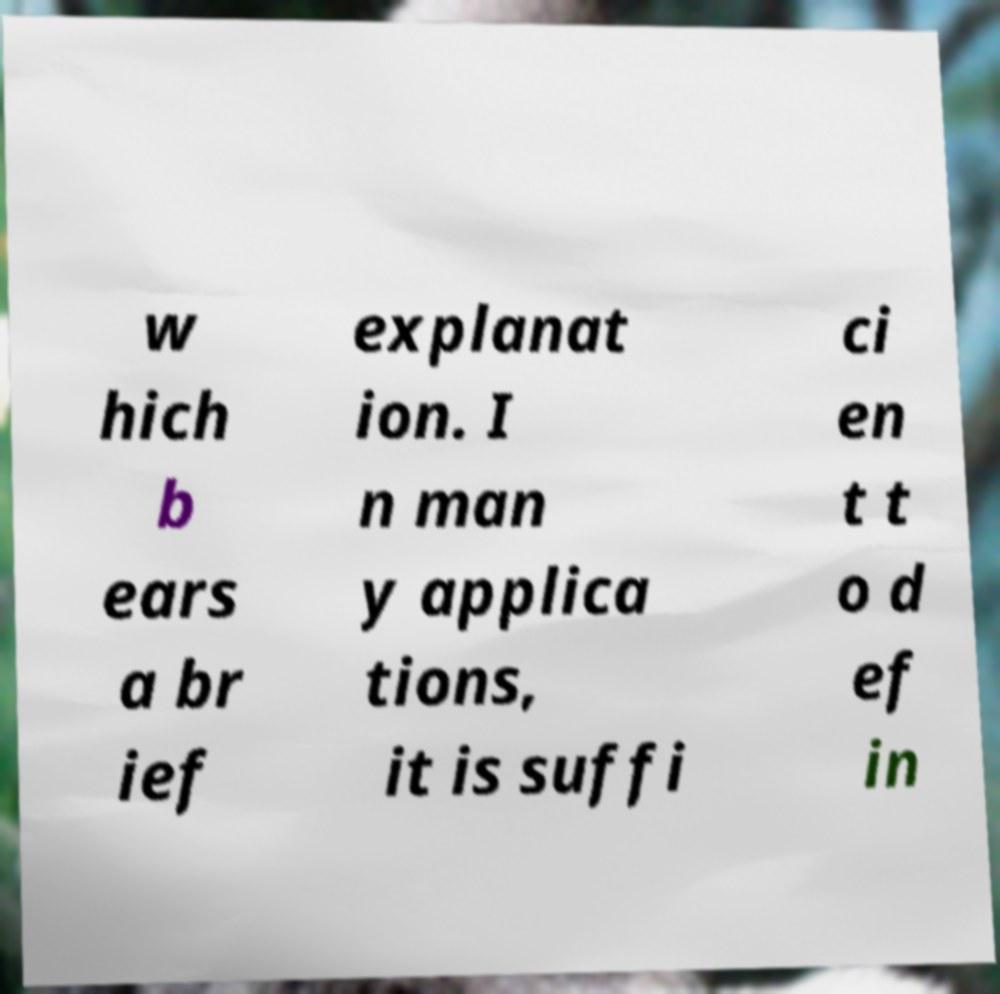Please identify and transcribe the text found in this image. w hich b ears a br ief explanat ion. I n man y applica tions, it is suffi ci en t t o d ef in 